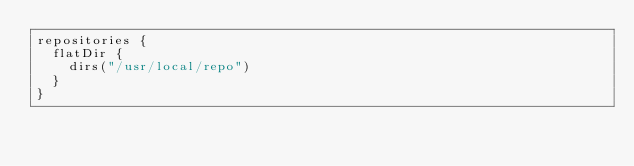<code> <loc_0><loc_0><loc_500><loc_500><_Kotlin_>repositories {
  flatDir {
    dirs("/usr/local/repo")
  }
}
</code> 